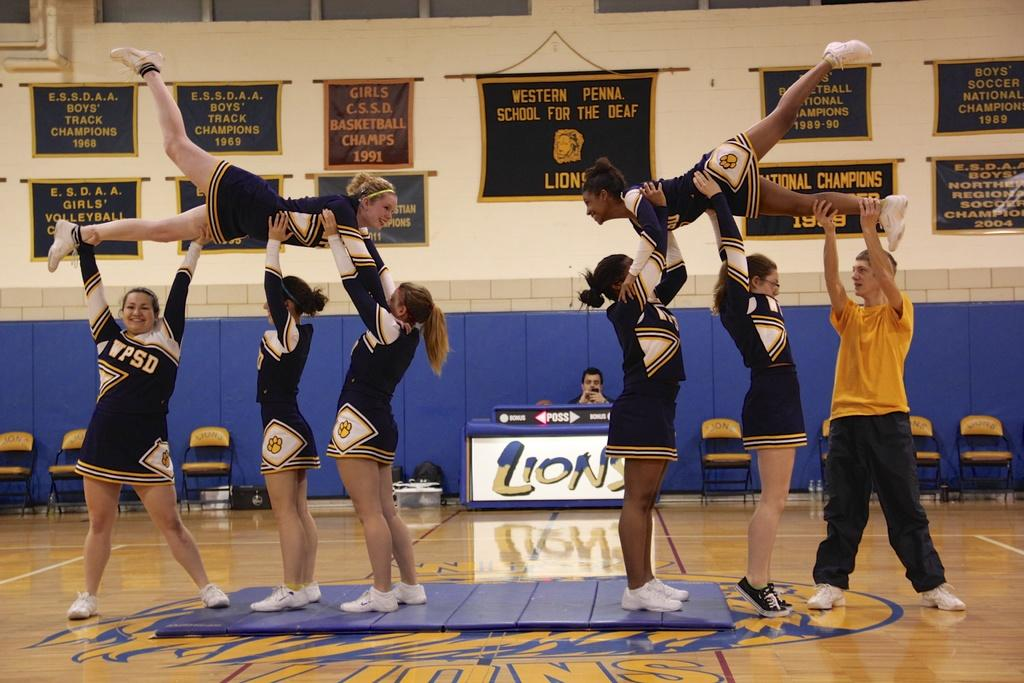<image>
Describe the image concisely. Cheerleaders from WPDS are performing pyramid stunts in a gym. 